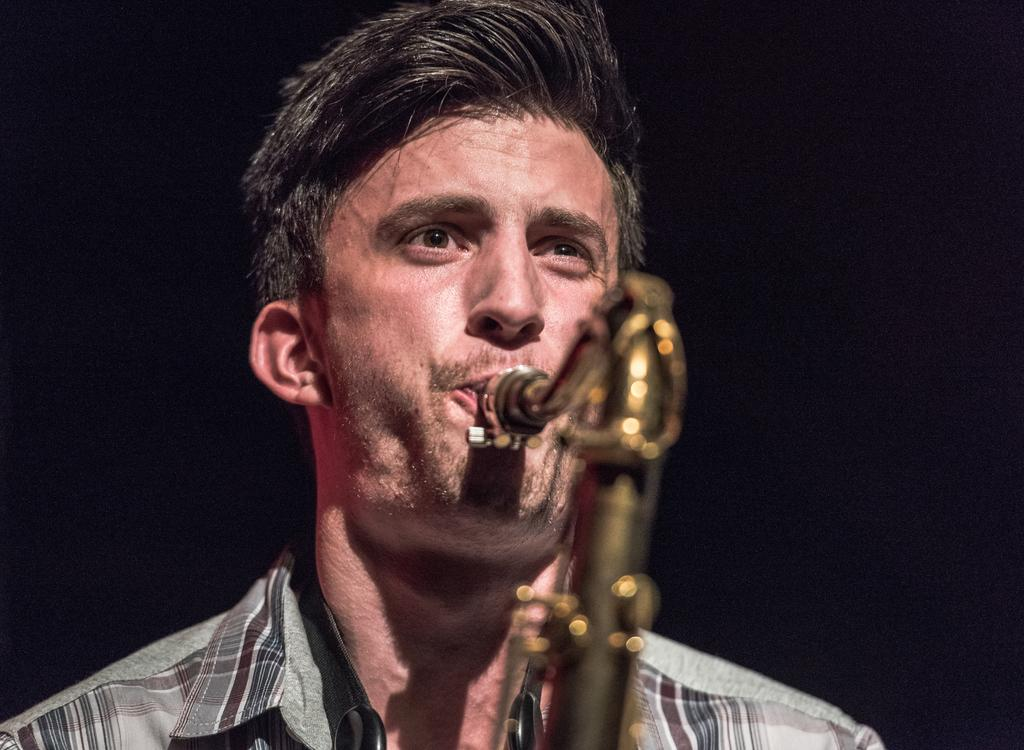Who is the main subject in the image? There is a man in the image. What is the man doing in the image? The man is playing a musical instrument with his mouth. What can be observed about the background of the image? The background of the image is dark. What type of bread is being used to support the government in the image? There is no bread or reference to a government in the image; it features a man playing a musical instrument with his mouth against a dark background. 